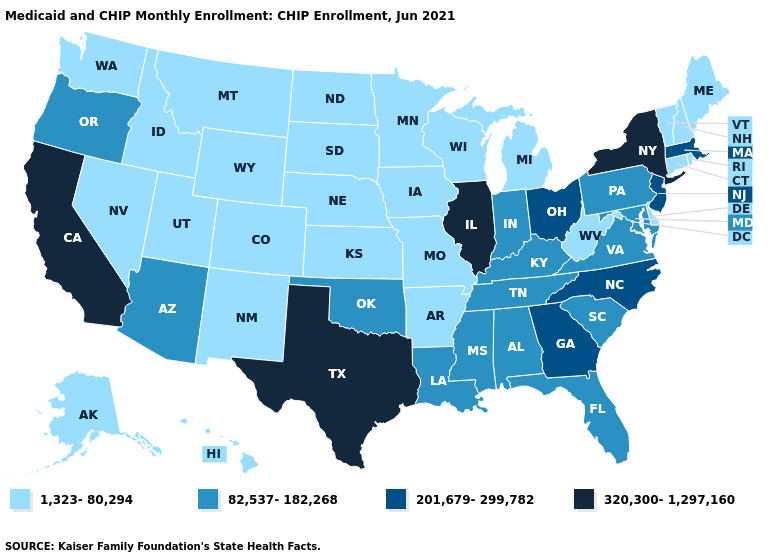What is the value of South Dakota?
Give a very brief answer. 1,323-80,294. Among the states that border New Jersey , does New York have the highest value?
Concise answer only. Yes. What is the highest value in the USA?
Quick response, please. 320,300-1,297,160. What is the value of Vermont?
Keep it brief. 1,323-80,294. Name the states that have a value in the range 320,300-1,297,160?
Quick response, please. California, Illinois, New York, Texas. Which states have the highest value in the USA?
Give a very brief answer. California, Illinois, New York, Texas. Name the states that have a value in the range 82,537-182,268?
Write a very short answer. Alabama, Arizona, Florida, Indiana, Kentucky, Louisiana, Maryland, Mississippi, Oklahoma, Oregon, Pennsylvania, South Carolina, Tennessee, Virginia. Among the states that border Maine , which have the highest value?
Keep it brief. New Hampshire. Is the legend a continuous bar?
Write a very short answer. No. Does Massachusetts have the same value as Wyoming?
Give a very brief answer. No. Name the states that have a value in the range 82,537-182,268?
Concise answer only. Alabama, Arizona, Florida, Indiana, Kentucky, Louisiana, Maryland, Mississippi, Oklahoma, Oregon, Pennsylvania, South Carolina, Tennessee, Virginia. Does Alabama have a higher value than Indiana?
Quick response, please. No. Is the legend a continuous bar?
Short answer required. No. Name the states that have a value in the range 201,679-299,782?
Answer briefly. Georgia, Massachusetts, New Jersey, North Carolina, Ohio. What is the lowest value in the Northeast?
Quick response, please. 1,323-80,294. 